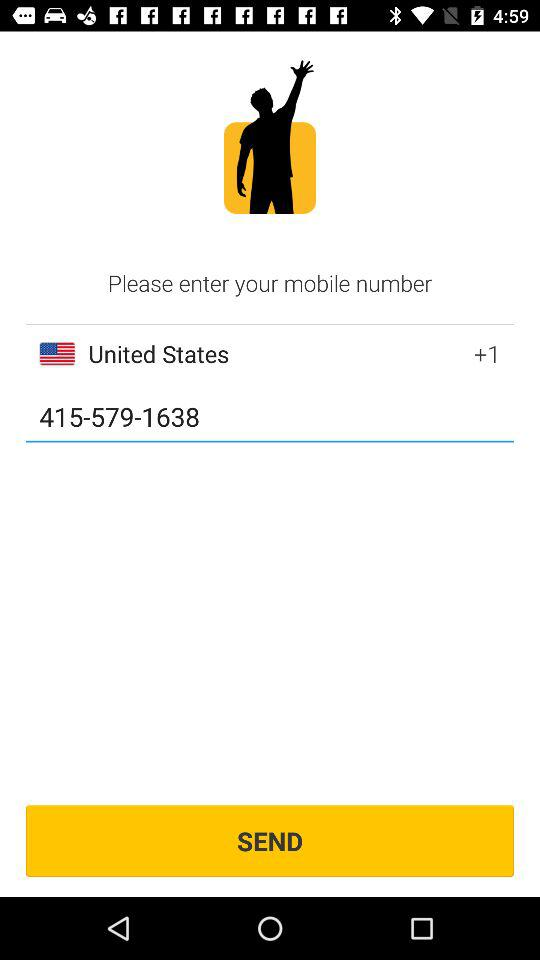How many digits are in the phone number?
Answer the question using a single word or phrase. 10 